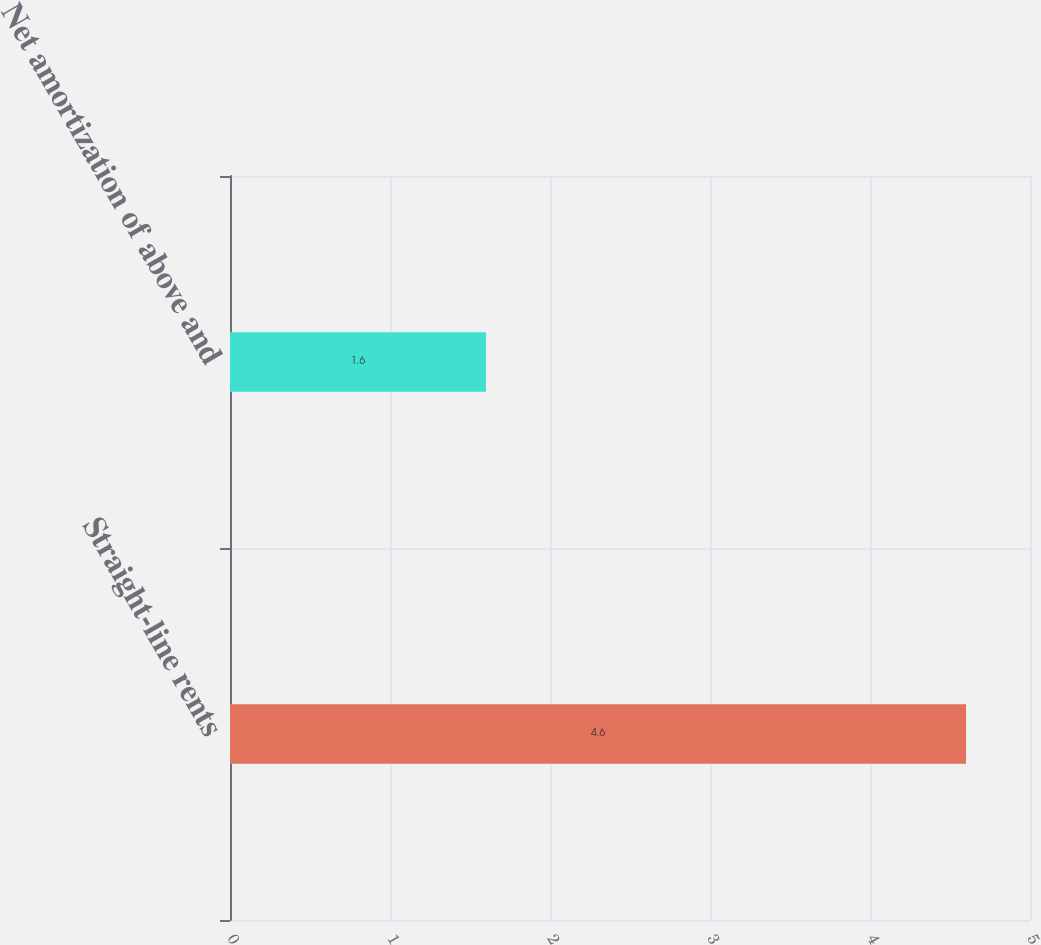Convert chart to OTSL. <chart><loc_0><loc_0><loc_500><loc_500><bar_chart><fcel>Straight-line rents<fcel>Net amortization of above and<nl><fcel>4.6<fcel>1.6<nl></chart> 